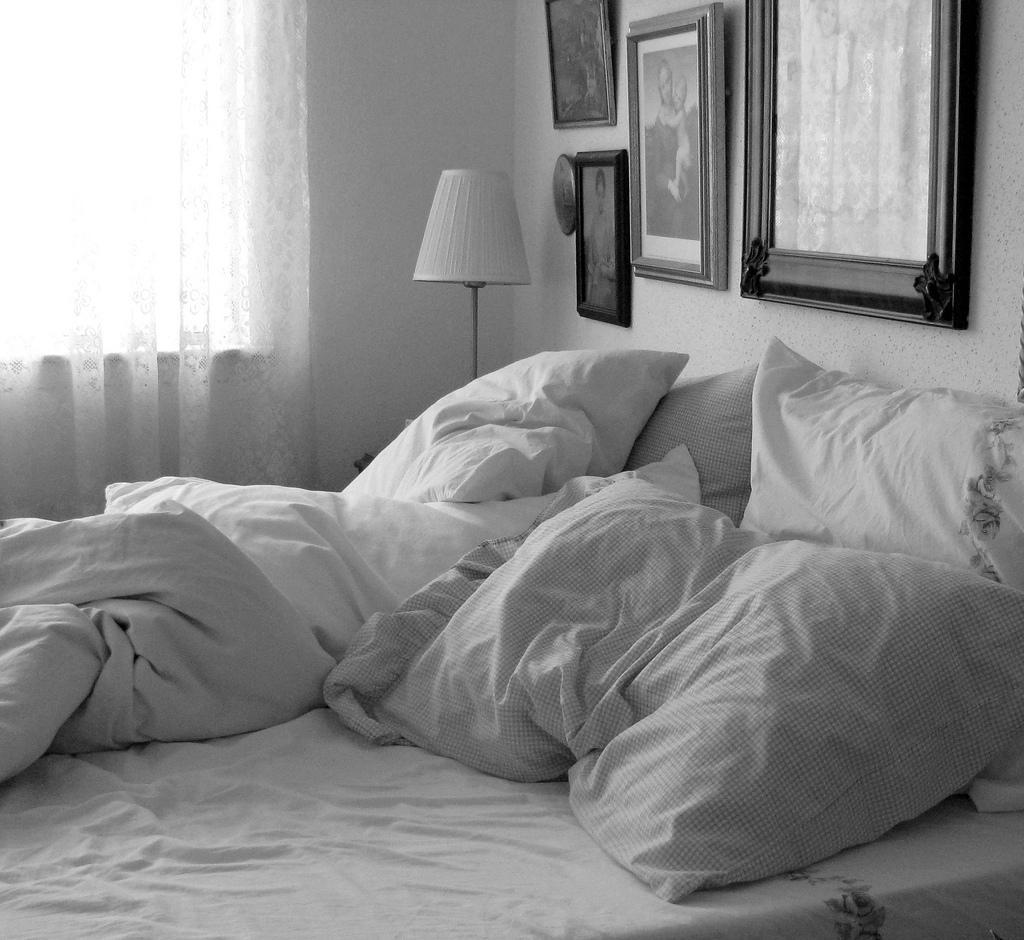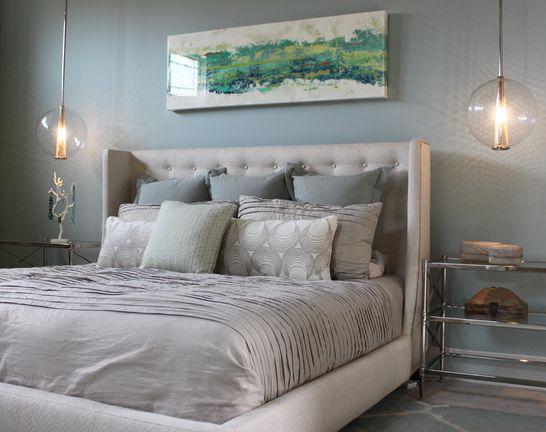The first image is the image on the left, the second image is the image on the right. Considering the images on both sides, is "One bed has an upholstered headboard." valid? Answer yes or no. Yes. 